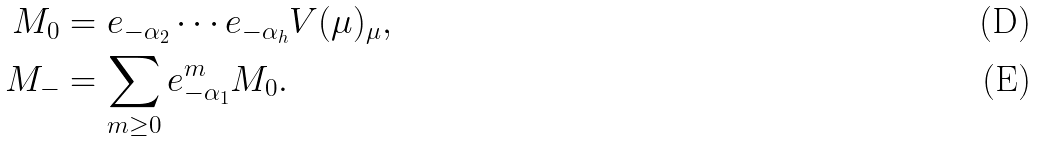<formula> <loc_0><loc_0><loc_500><loc_500>M _ { 0 } & = e _ { - \alpha _ { 2 } } \cdots e _ { - \alpha _ { h } } V ( \mu ) _ { \mu } , \\ M _ { - } & = \sum _ { m \geq 0 } e _ { - \alpha _ { 1 } } ^ { m } M _ { 0 } .</formula> 